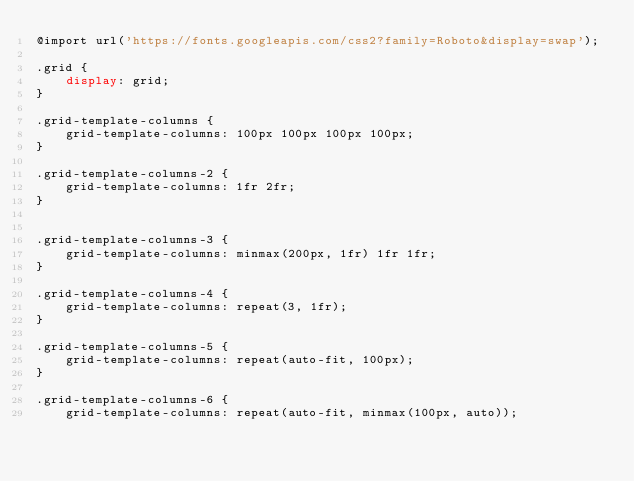Convert code to text. <code><loc_0><loc_0><loc_500><loc_500><_CSS_>@import url('https://fonts.googleapis.com/css2?family=Roboto&display=swap');

.grid {
    display: grid;
}

.grid-template-columns {
    grid-template-columns: 100px 100px 100px 100px;
}

.grid-template-columns-2 {
    grid-template-columns: 1fr 2fr;
}


.grid-template-columns-3 {
    grid-template-columns: minmax(200px, 1fr) 1fr 1fr;
}

.grid-template-columns-4 {
    grid-template-columns: repeat(3, 1fr);
}

.grid-template-columns-5 {
    grid-template-columns: repeat(auto-fit, 100px);
}

.grid-template-columns-6 {
    grid-template-columns: repeat(auto-fit, minmax(100px, auto));</code> 